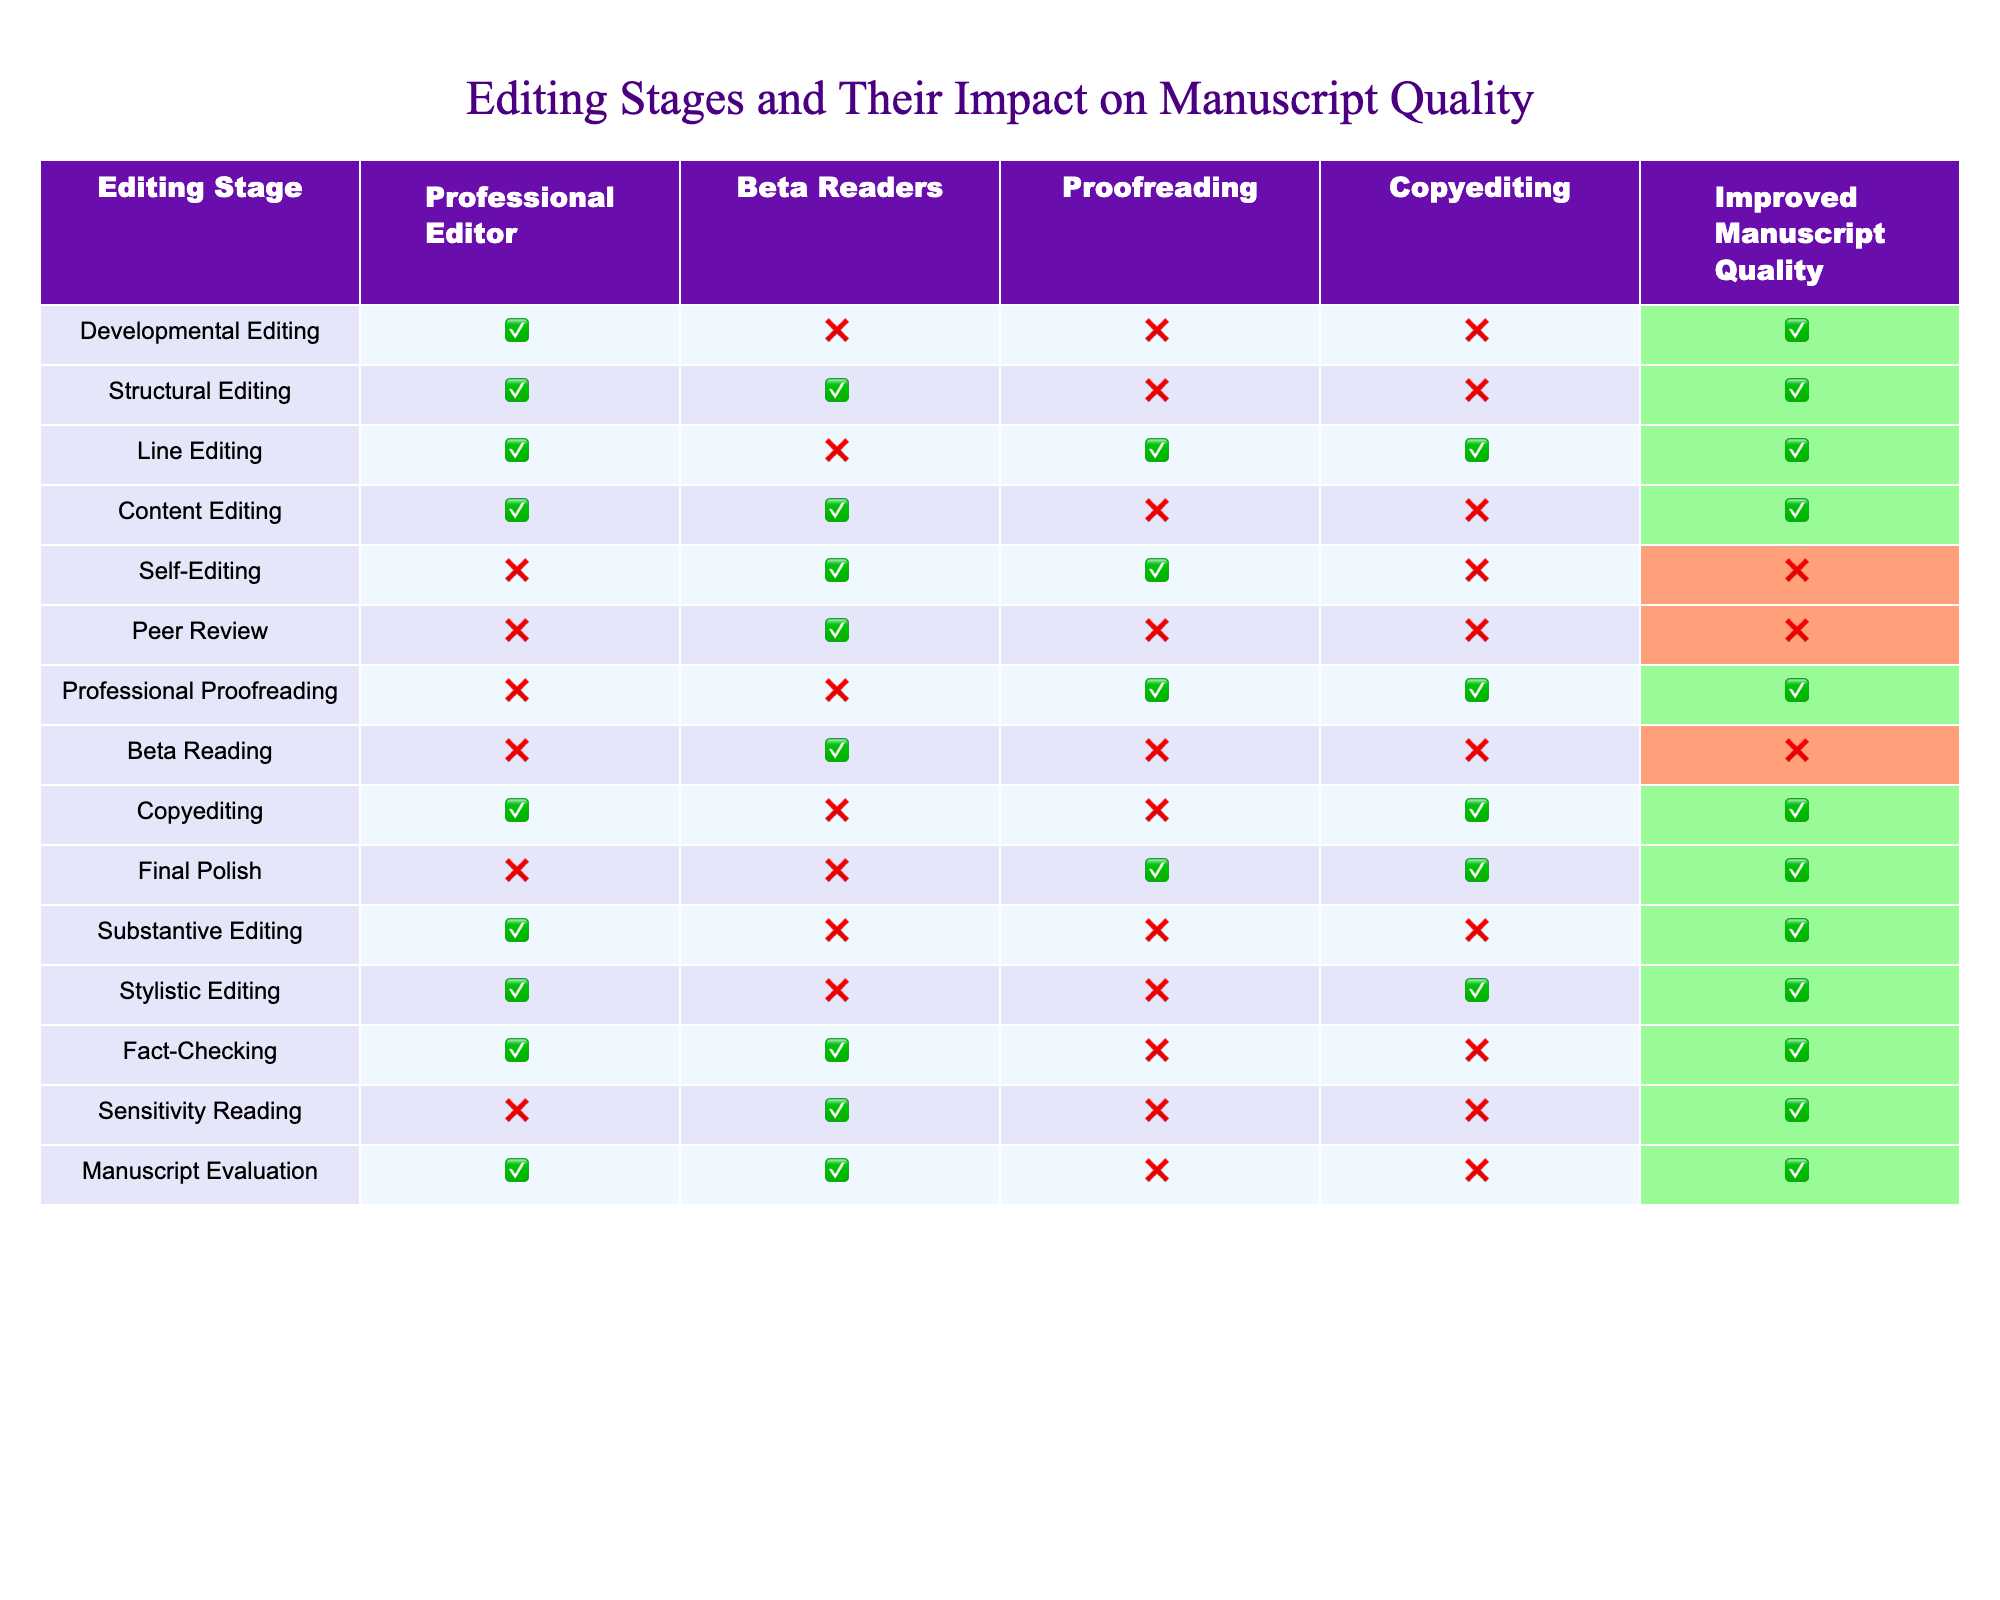What editing stage includes input from beta readers and improves manuscript quality? The Structural Editing stage includes a professional editor and beta readers, as shown in the table. Both are required for this stage, and it leads to improved manuscript quality.
Answer: Structural Editing How many editing stages achieve improved manuscript quality through professional editing alone? The table shows that Developmental Editing, Line Editing, Content Editing, Copyediting, Substantive Editing, and Stylistic Editing improve manuscript quality with the professional editor's involvement. That sums up to 6 stages.
Answer: 6 Which editing stage does not involve any professional editor but includes beta readers and improves manuscript quality? According to the table, the Sensitivity Reading stage includes beta readers, does not involve a professional editor, and results in improved manuscript quality.
Answer: Sensitivity Reading Is it true that all editing stages with proofreading result in improved manuscript quality? By examining the table, only Line Editing, Professional Proofreading, Copyediting, and Final Polish involve proofreading and improve manuscript quality. Other stages either do not improve quality or do not involve proofreading, indicating it is not true that all involve it.
Answer: No Arrange the three editing stages with the highest number of total contributors (professional editor, beta readers, proofreading, copyediting) in descending order. The total contributors for each stage can be counted: Structural Editing and Line Editing both have 4 contributors, while Developmental Editing, Content Editing, and Copyediting have 3. Sorting these yields Structural Editing and Line Editing (4), followed by Developmental Editing, Content Editing, and Copyediting (3 each) ranked together.
Answer: Structural Editing, Line Editing, Developmental Editing/Copyrighting/Content Editing (tie) What is the relationship between peer review and the improvement of manuscript quality? The table indicates that peer review involves beta readers but does not improve manuscript quality, as it is marked with a '0' in the corresponding column. Thus, there is no positive relationship between peer review and manuscript quality improvement.
Answer: No relationship Which editing stage improves manuscript quality with only a line editor involved? The Line Editing stage improves manuscript quality with the involvement of a professional editor and a line editor, making it unique for being solely associated with line editing.
Answer: Line Editing Count how many editing stages are effective only through self-editing involving beta readers. Only one stage, Self-Editing, meets the criteria as it solely includes beta readers without professional editing, proofreading, or copyediting, marking it as ineffective for improving manuscript quality.
Answer: 1 